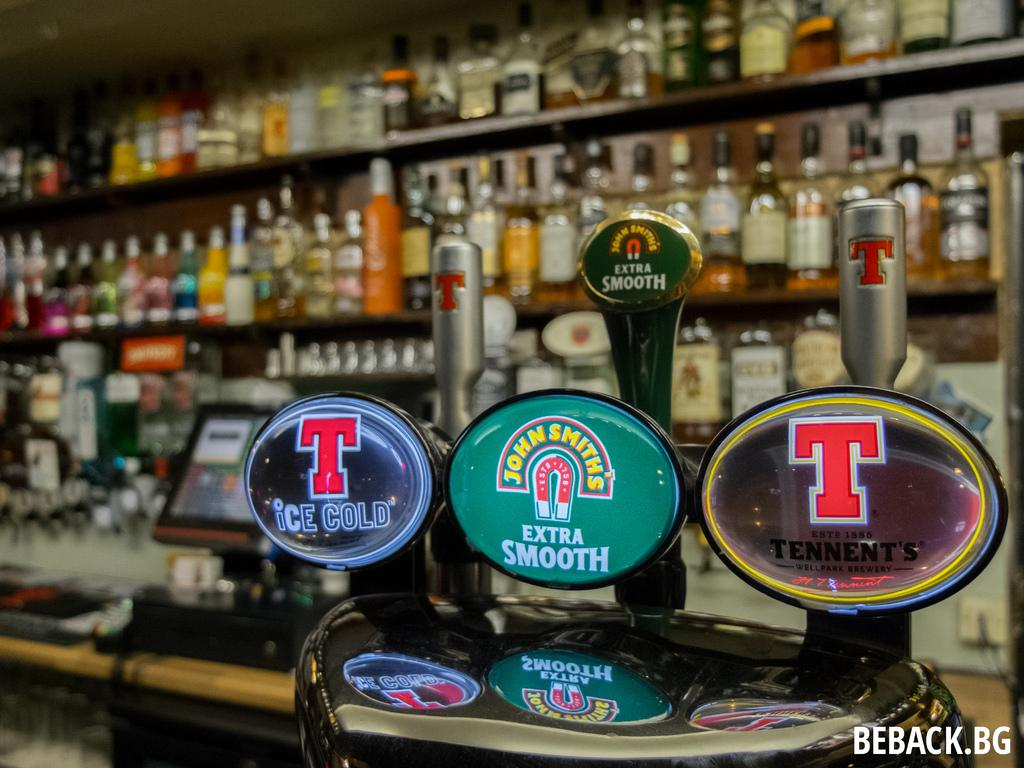What is the main object in the image? There is a monitor in the image. What is the monitor placed on? There is a table in the image. What can be seen on the table? There are objects visible in the image. What is written at the bottom of the image? There is writing at the bottom of the image. What is visible in the background of the image? There are bottles on racks in the background of the image. What song is the beggar singing in the image? There is no beggar or song present in the image. What type of needle is being used to sew the fabric in the image? There is no needle or fabric present in the image. 